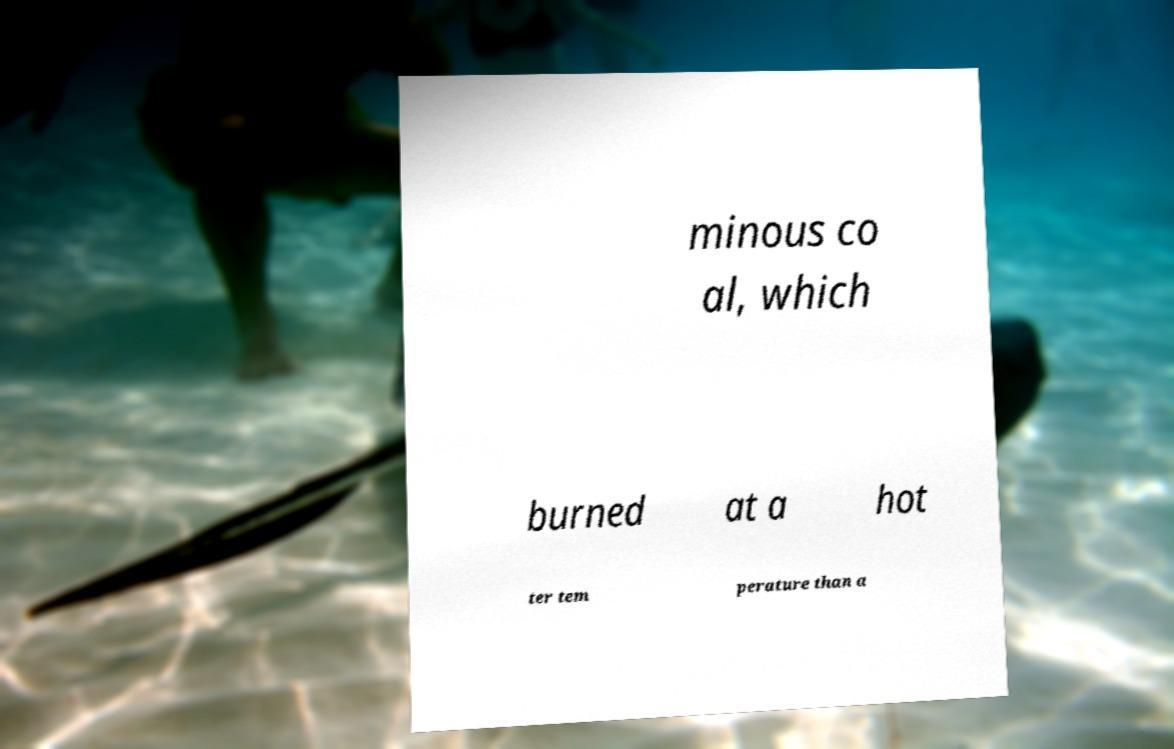Can you accurately transcribe the text from the provided image for me? minous co al, which burned at a hot ter tem perature than a 